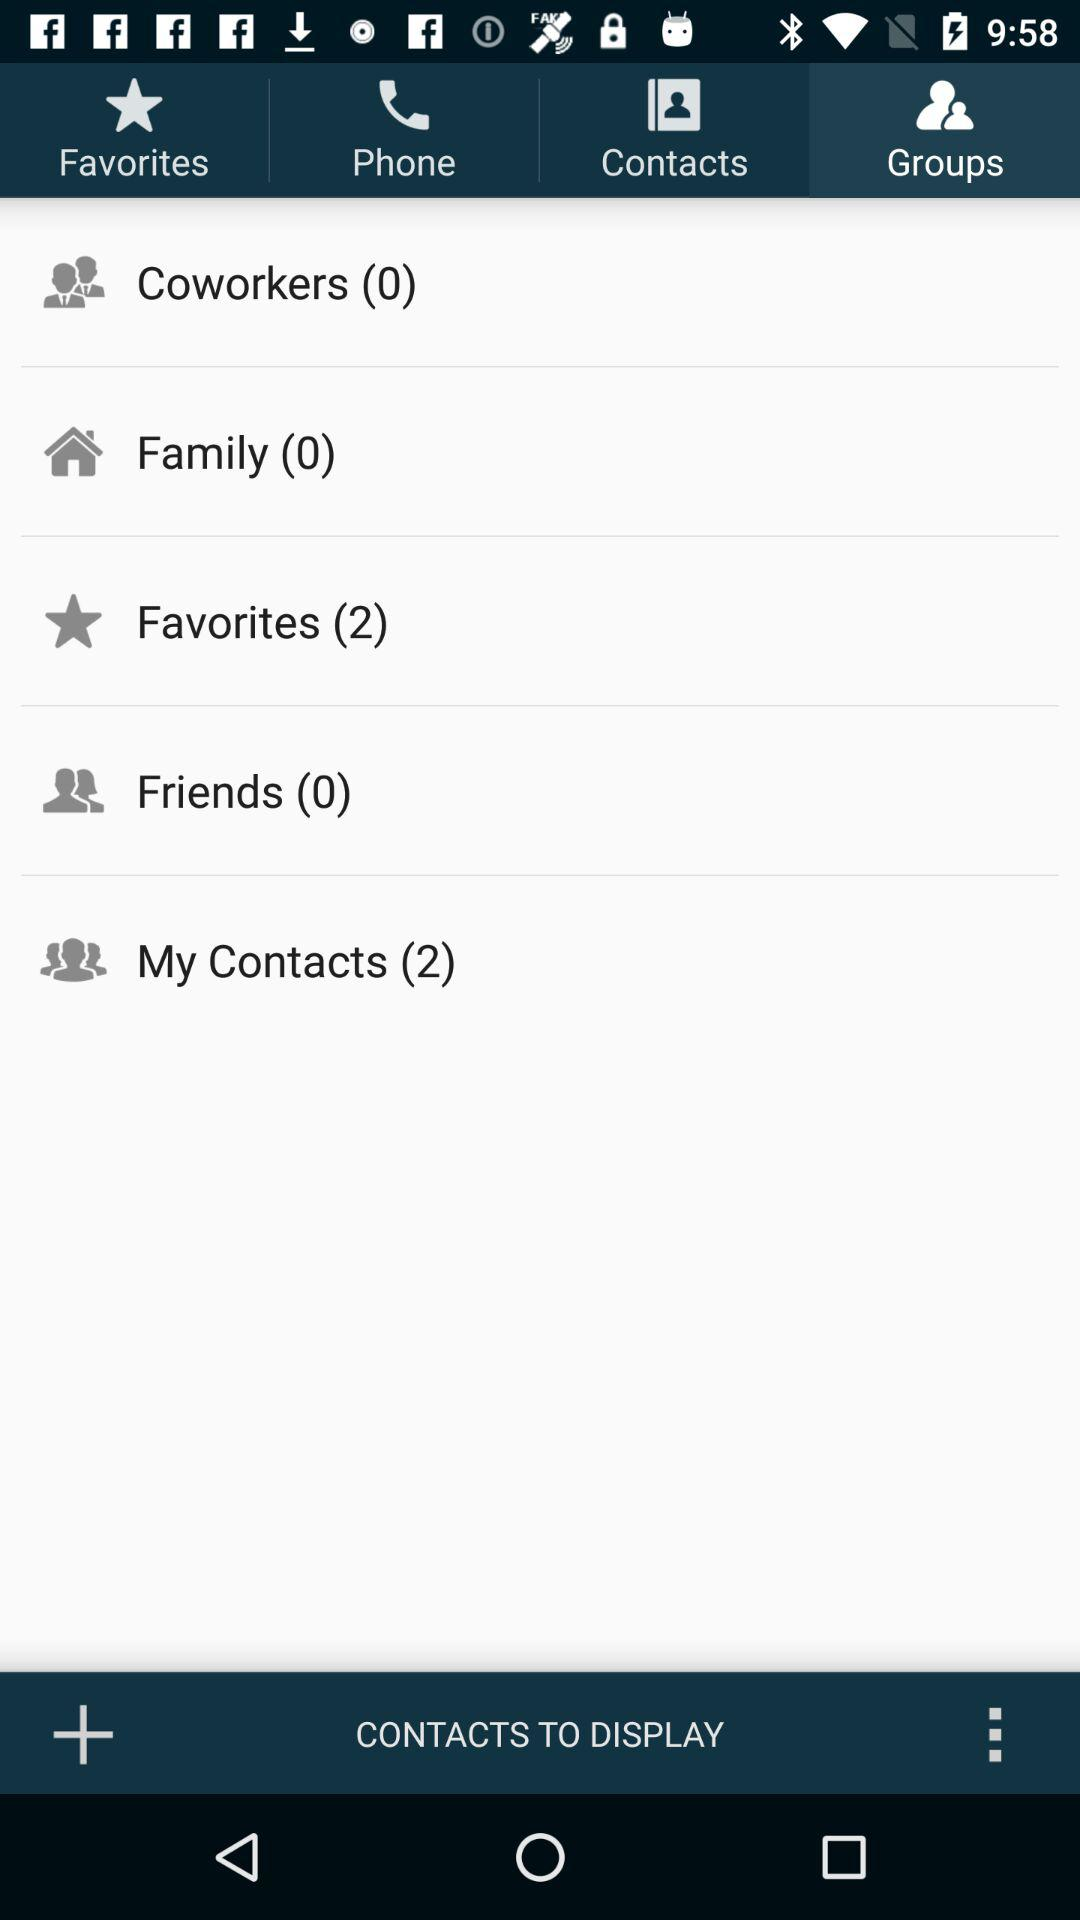Which tab is selected? The selected tab is "Groups". 